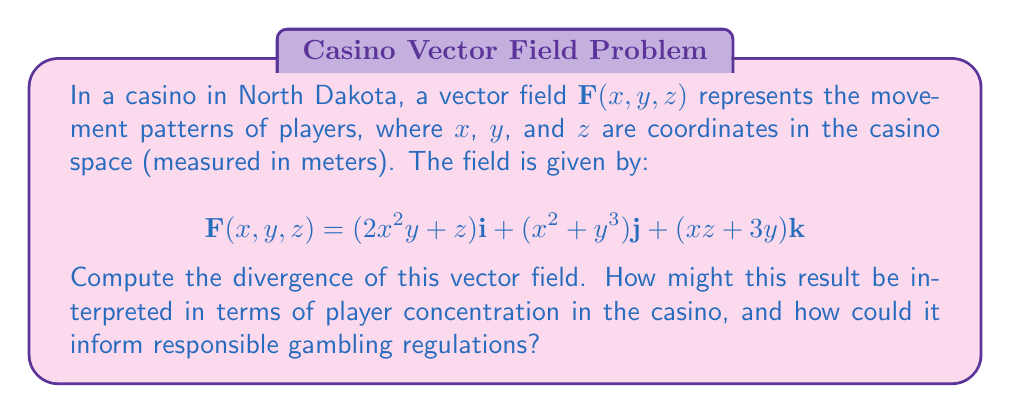Can you solve this math problem? To compute the divergence of the vector field, we need to calculate the partial derivatives of each component with respect to its corresponding variable and sum them up. The divergence is given by:

$$\text{div}\mathbf{F} = \nabla \cdot \mathbf{F} = \frac{\partial F_x}{\partial x} + \frac{\partial F_y}{\partial y} + \frac{\partial F_z}{\partial z}$$

Let's calculate each partial derivative:

1. $\frac{\partial F_x}{\partial x} = \frac{\partial}{\partial x}(2x^2y + z) = 4xy$

2. $\frac{\partial F_y}{\partial y} = \frac{\partial}{\partial y}(x^2 + y^3) = 3y^2$

3. $\frac{\partial F_z}{\partial z} = \frac{\partial}{\partial z}(xz + 3y) = x$

Now, we sum these partial derivatives:

$$\text{div}\mathbf{F} = 4xy + 3y^2 + x$$

This result represents the rate at which the density of players is changing at any point in the casino. A positive divergence indicates areas where players are accumulating, while a negative divergence suggests areas where players are dispersing.

Interpretation: The divergence varies depending on the location in the casino. Areas with higher $x$ and $y$ coordinates will have a higher divergence, indicating a greater concentration of players. This information could be used to identify potential hotspots for gambling activity.

For responsible gambling regulations, this analysis could help:
1. Identify areas that may need additional monitoring or staff presence.
2. Guide the placement of responsible gambling information and resources.
3. Inform decisions on game placement to avoid creating overly concentrated areas of high-intensity gambling.
Answer: $$\text{div}\mathbf{F} = 4xy + 3y^2 + x$$ 